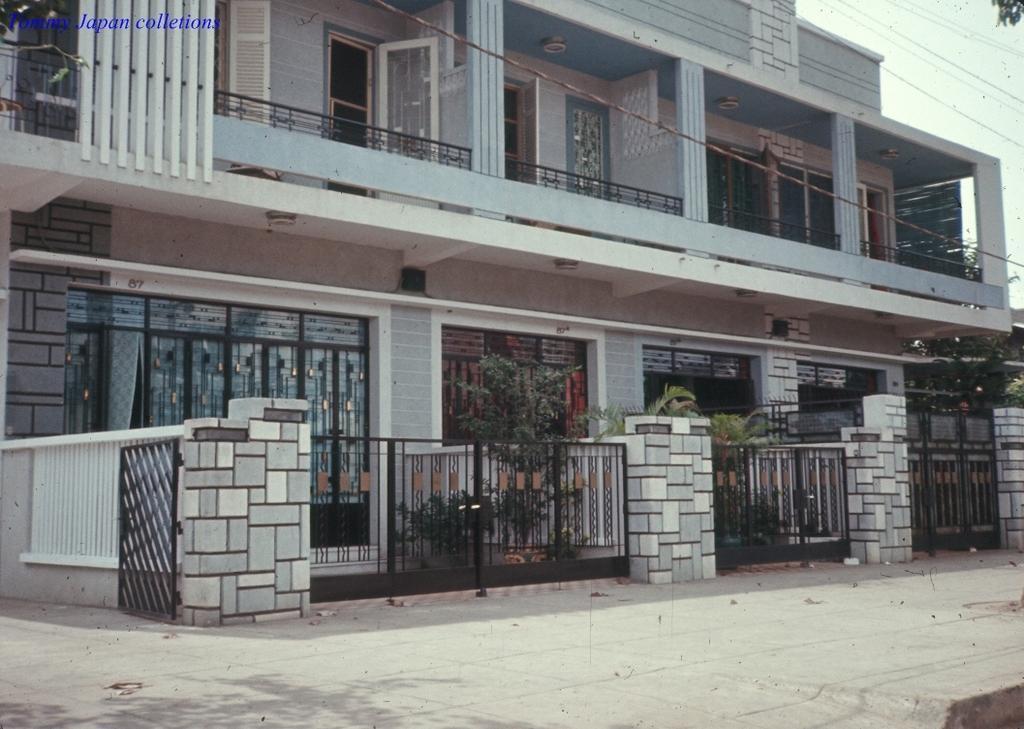Could you give a brief overview of what you see in this image? In this image I can see buildings. There are gates, windows, plants , cables and there is sky. 